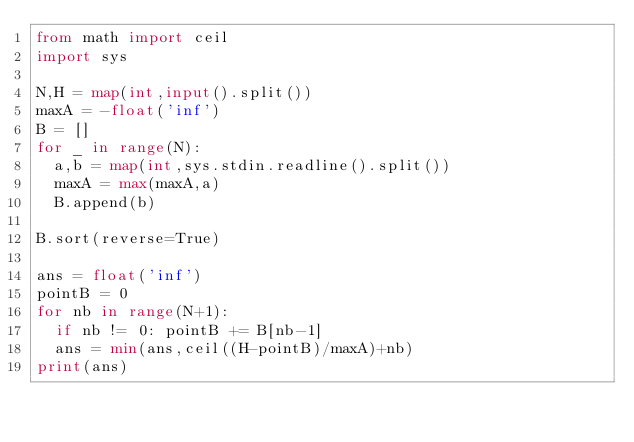Convert code to text. <code><loc_0><loc_0><loc_500><loc_500><_Python_>from math import ceil
import sys

N,H = map(int,input().split())
maxA = -float('inf')
B = []
for _ in range(N):
  a,b = map(int,sys.stdin.readline().split())
  maxA = max(maxA,a)
  B.append(b)

B.sort(reverse=True)

ans = float('inf')
pointB = 0
for nb in range(N+1):
  if nb != 0: pointB += B[nb-1]
  ans = min(ans,ceil((H-pointB)/maxA)+nb)
print(ans)</code> 